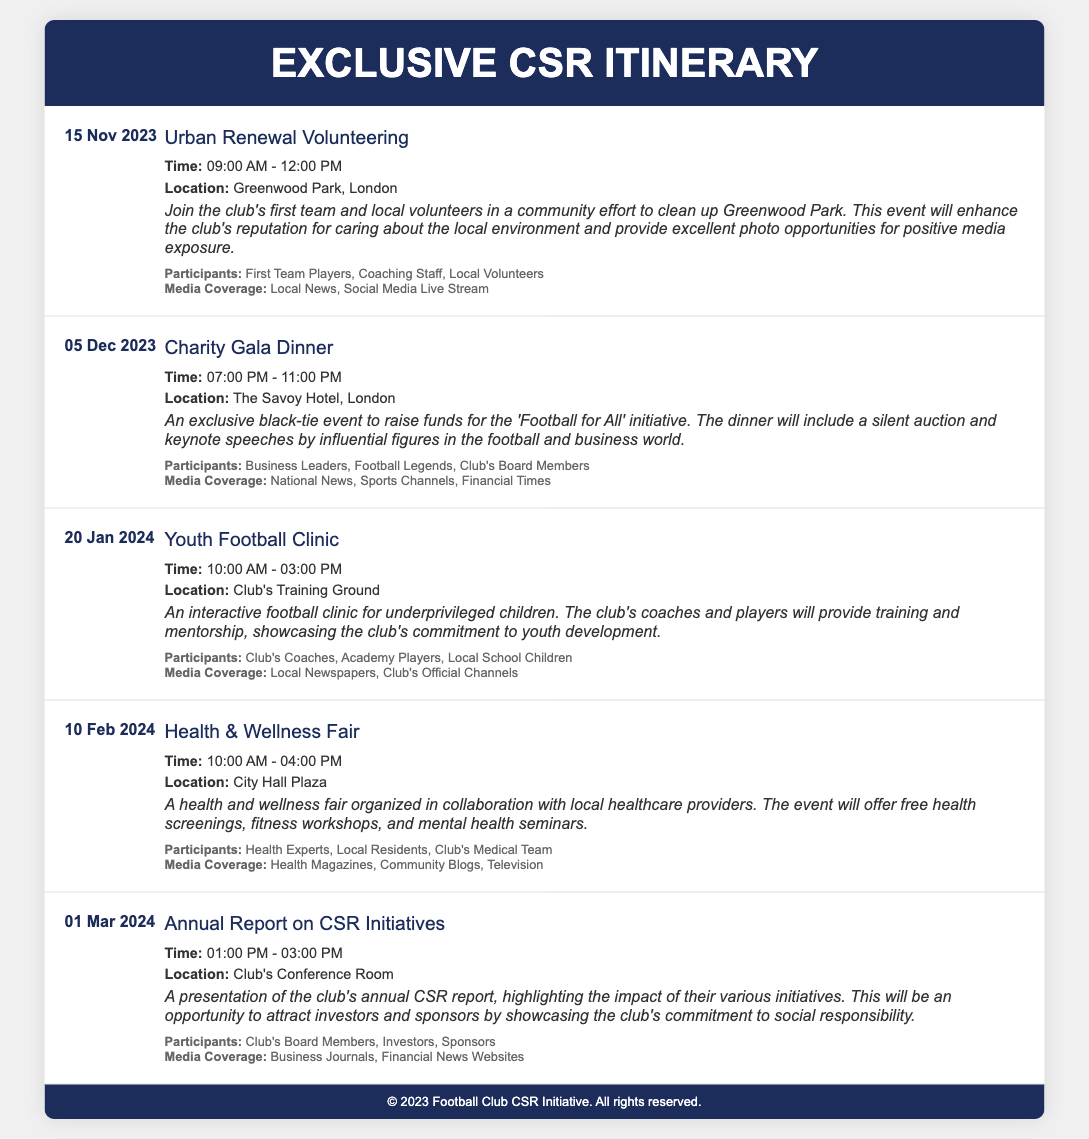What is the date of the Urban Renewal Volunteering event? The date can be found at the beginning of the event section.
Answer: 15 Nov 2023 Where will the Charity Gala Dinner take place? The location is specified within the event details.
Answer: The Savoy Hotel, London What time does the Youth Football Clinic start? The start time is indicated in the event information.
Answer: 10:00 AM Which event includes a silent auction? The silent auction is mentioned in the description of the related event.
Answer: Charity Gala Dinner Who will be participating in the Health & Wellness Fair? The participants are listed under each event section.
Answer: Health Experts, Local Residents, Club's Medical Team What is the focus of the Annual Report on CSR Initiatives? The purpose of the event is outlined in the description.
Answer: The impact of their various initiatives When is the Health & Wellness Fair scheduled? The date is provided in the event section.
Answer: 10 Feb 2024 What type of media coverage is associated with the Urban Renewal Volunteering event? Media coverage details are included in the event's description.
Answer: Local News, Social Media Live Stream 